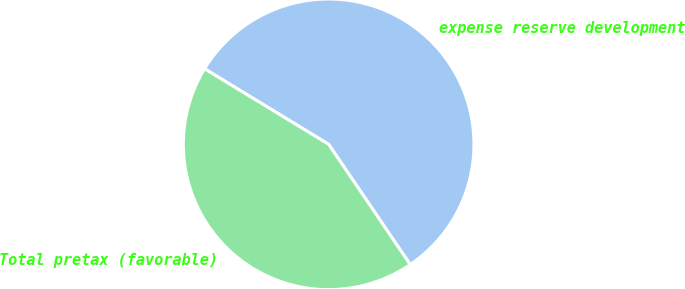Convert chart to OTSL. <chart><loc_0><loc_0><loc_500><loc_500><pie_chart><fcel>expense reserve development<fcel>Total pretax (favorable)<nl><fcel>56.81%<fcel>43.19%<nl></chart> 